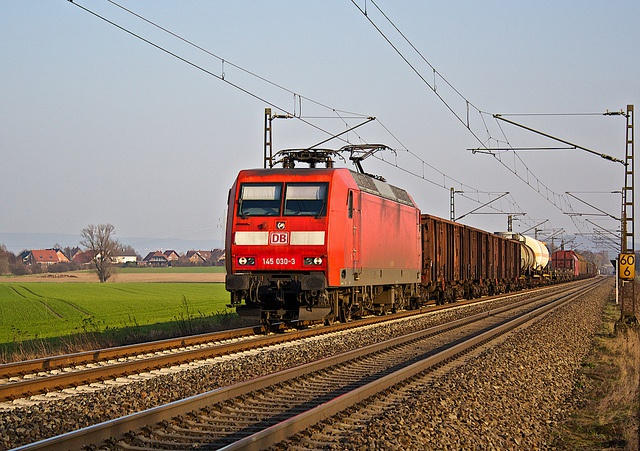Describe the objects in this image and their specific colors. I can see a train in lightblue, black, maroon, salmon, and red tones in this image. 